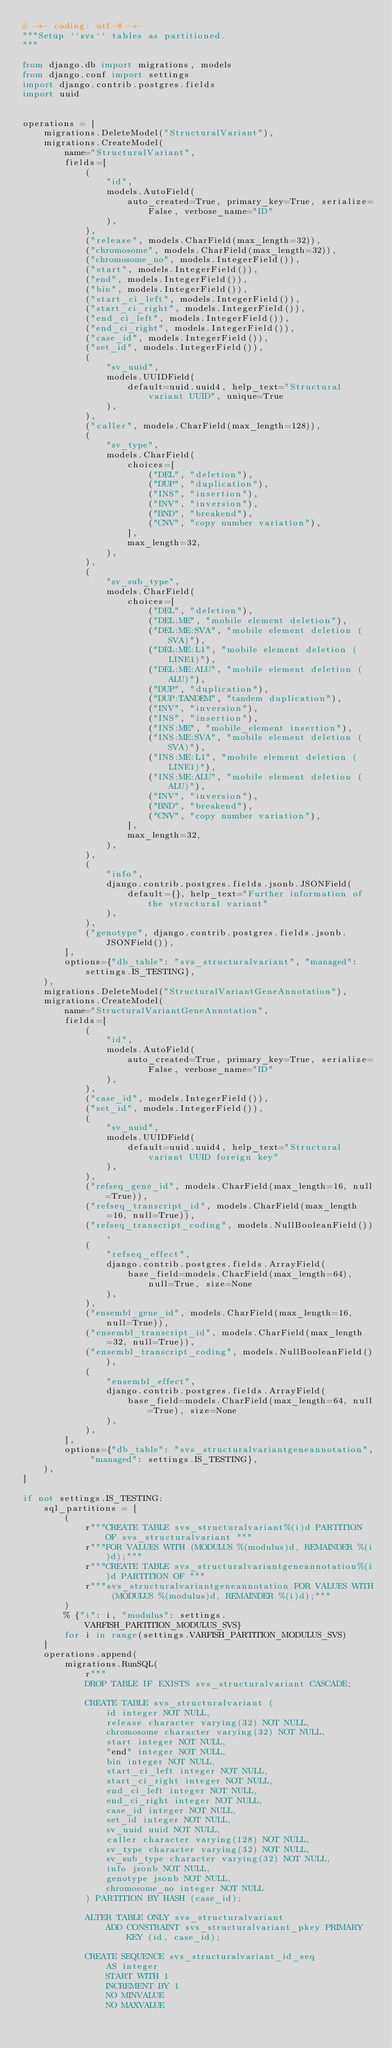<code> <loc_0><loc_0><loc_500><loc_500><_Python_># -*- coding: utf-8 -*-
"""Setup ``svs`` tables as partitioned.
"""

from django.db import migrations, models
from django.conf import settings
import django.contrib.postgres.fields
import uuid


operations = [
    migrations.DeleteModel("StructuralVariant"),
    migrations.CreateModel(
        name="StructuralVariant",
        fields=[
            (
                "id",
                models.AutoField(
                    auto_created=True, primary_key=True, serialize=False, verbose_name="ID"
                ),
            ),
            ("release", models.CharField(max_length=32)),
            ("chromosome", models.CharField(max_length=32)),
            ("chromosome_no", models.IntegerField()),
            ("start", models.IntegerField()),
            ("end", models.IntegerField()),
            ("bin", models.IntegerField()),
            ("start_ci_left", models.IntegerField()),
            ("start_ci_right", models.IntegerField()),
            ("end_ci_left", models.IntegerField()),
            ("end_ci_right", models.IntegerField()),
            ("case_id", models.IntegerField()),
            ("set_id", models.IntegerField()),
            (
                "sv_uuid",
                models.UUIDField(
                    default=uuid.uuid4, help_text="Structural variant UUID", unique=True
                ),
            ),
            ("caller", models.CharField(max_length=128)),
            (
                "sv_type",
                models.CharField(
                    choices=[
                        ("DEL", "deletion"),
                        ("DUP", "duplication"),
                        ("INS", "insertion"),
                        ("INV", "inversion"),
                        ("BND", "breakend"),
                        ("CNV", "copy number variation"),
                    ],
                    max_length=32,
                ),
            ),
            (
                "sv_sub_type",
                models.CharField(
                    choices=[
                        ("DEL", "deletion"),
                        ("DEL:ME", "mobile element deletion"),
                        ("DEL:ME:SVA", "mobile element deletion (SVA)"),
                        ("DEL:ME:L1", "mobile element deletion (LINE1)"),
                        ("DEL:ME:ALU", "mobile element deletion (ALU)"),
                        ("DUP", "duplication"),
                        ("DUP:TANDEM", "tandem duplication"),
                        ("INV", "inversion"),
                        ("INS", "insertion"),
                        ("INS:ME", "mobile_element insertion"),
                        ("INS:ME:SVA", "mobile element deletion (SVA)"),
                        ("INS:ME:L1", "mobile element deletion (LINE1)"),
                        ("INS:ME:ALU", "mobile element deletion (ALU)"),
                        ("INV", "inversion"),
                        ("BND", "breakend"),
                        ("CNV", "copy number variation"),
                    ],
                    max_length=32,
                ),
            ),
            (
                "info",
                django.contrib.postgres.fields.jsonb.JSONField(
                    default={}, help_text="Further information of the structural variant"
                ),
            ),
            ("genotype", django.contrib.postgres.fields.jsonb.JSONField()),
        ],
        options={"db_table": "svs_structuralvariant", "managed": settings.IS_TESTING},
    ),
    migrations.DeleteModel("StructuralVariantGeneAnnotation"),
    migrations.CreateModel(
        name="StructuralVariantGeneAnnotation",
        fields=[
            (
                "id",
                models.AutoField(
                    auto_created=True, primary_key=True, serialize=False, verbose_name="ID"
                ),
            ),
            ("case_id", models.IntegerField()),
            ("set_id", models.IntegerField()),
            (
                "sv_uuid",
                models.UUIDField(
                    default=uuid.uuid4, help_text="Structural variant UUID foreign key"
                ),
            ),
            ("refseq_gene_id", models.CharField(max_length=16, null=True)),
            ("refseq_transcript_id", models.CharField(max_length=16, null=True)),
            ("refseq_transcript_coding", models.NullBooleanField()),
            (
                "refseq_effect",
                django.contrib.postgres.fields.ArrayField(
                    base_field=models.CharField(max_length=64), null=True, size=None
                ),
            ),
            ("ensembl_gene_id", models.CharField(max_length=16, null=True)),
            ("ensembl_transcript_id", models.CharField(max_length=32, null=True)),
            ("ensembl_transcript_coding", models.NullBooleanField()),
            (
                "ensembl_effect",
                django.contrib.postgres.fields.ArrayField(
                    base_field=models.CharField(max_length=64, null=True), size=None
                ),
            ),
        ],
        options={"db_table": "svs_structuralvariantgeneannotation", "managed": settings.IS_TESTING},
    ),
]

if not settings.IS_TESTING:
    sql_partitions = [
        (
            r"""CREATE TABLE svs_structuralvariant%(i)d PARTITION OF svs_structuralvariant """
            r"""FOR VALUES WITH (MODULUS %(modulus)d, REMAINDER %(i)d);"""
            r"""CREATE TABLE svs_structuralvariantgeneannotation%(i)d PARTITION OF """
            r"""svs_structuralvariantgeneannotation FOR VALUES WITH (MODULUS %(modulus)d, REMAINDER %(i)d);"""
        )
        % {"i": i, "modulus": settings.VARFISH_PARTITION_MODULUS_SVS}
        for i in range(settings.VARFISH_PARTITION_MODULUS_SVS)
    ]
    operations.append(
        migrations.RunSQL(
            r"""
            DROP TABLE IF EXISTS svs_structuralvariant CASCADE;

            CREATE TABLE svs_structuralvariant (
                id integer NOT NULL,
                release character varying(32) NOT NULL,
                chromosome character varying(32) NOT NULL,
                start integer NOT NULL,
                "end" integer NOT NULL,
                bin integer NOT NULL,
                start_ci_left integer NOT NULL,
                start_ci_right integer NOT NULL,
                end_ci_left integer NOT NULL,
                end_ci_right integer NOT NULL,
                case_id integer NOT NULL,
                set_id integer NOT NULL,
                sv_uuid uuid NOT NULL,
                caller character varying(128) NOT NULL,
                sv_type character varying(32) NOT NULL,
                sv_sub_type character varying(32) NOT NULL,
                info jsonb NOT NULL,
                genotype jsonb NOT NULL,
                chromosome_no integer NOT NULL
            ) PARTITION BY HASH (case_id);

            ALTER TABLE ONLY svs_structuralvariant
                ADD CONSTRAINT svs_structuralvariant_pkey PRIMARY KEY (id, case_id);

            CREATE SEQUENCE svs_structuralvariant_id_seq
                AS integer
                START WITH 1
                INCREMENT BY 1
                NO MINVALUE
                NO MAXVALUE</code> 